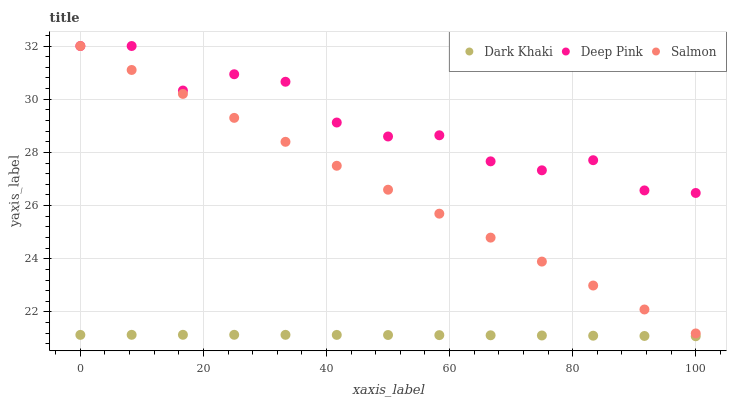Does Dark Khaki have the minimum area under the curve?
Answer yes or no. Yes. Does Deep Pink have the maximum area under the curve?
Answer yes or no. Yes. Does Salmon have the minimum area under the curve?
Answer yes or no. No. Does Salmon have the maximum area under the curve?
Answer yes or no. No. Is Salmon the smoothest?
Answer yes or no. Yes. Is Deep Pink the roughest?
Answer yes or no. Yes. Is Deep Pink the smoothest?
Answer yes or no. No. Is Salmon the roughest?
Answer yes or no. No. Does Dark Khaki have the lowest value?
Answer yes or no. Yes. Does Salmon have the lowest value?
Answer yes or no. No. Does Salmon have the highest value?
Answer yes or no. Yes. Is Dark Khaki less than Salmon?
Answer yes or no. Yes. Is Deep Pink greater than Dark Khaki?
Answer yes or no. Yes. Does Deep Pink intersect Salmon?
Answer yes or no. Yes. Is Deep Pink less than Salmon?
Answer yes or no. No. Is Deep Pink greater than Salmon?
Answer yes or no. No. Does Dark Khaki intersect Salmon?
Answer yes or no. No. 